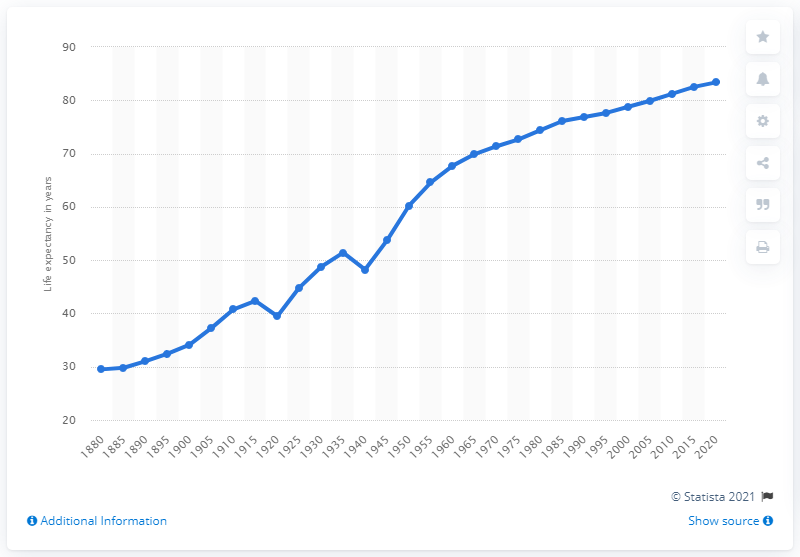Give some essential details in this illustration. In the year 1880, the life expectancy of the Spanish population was below thirty years old. 